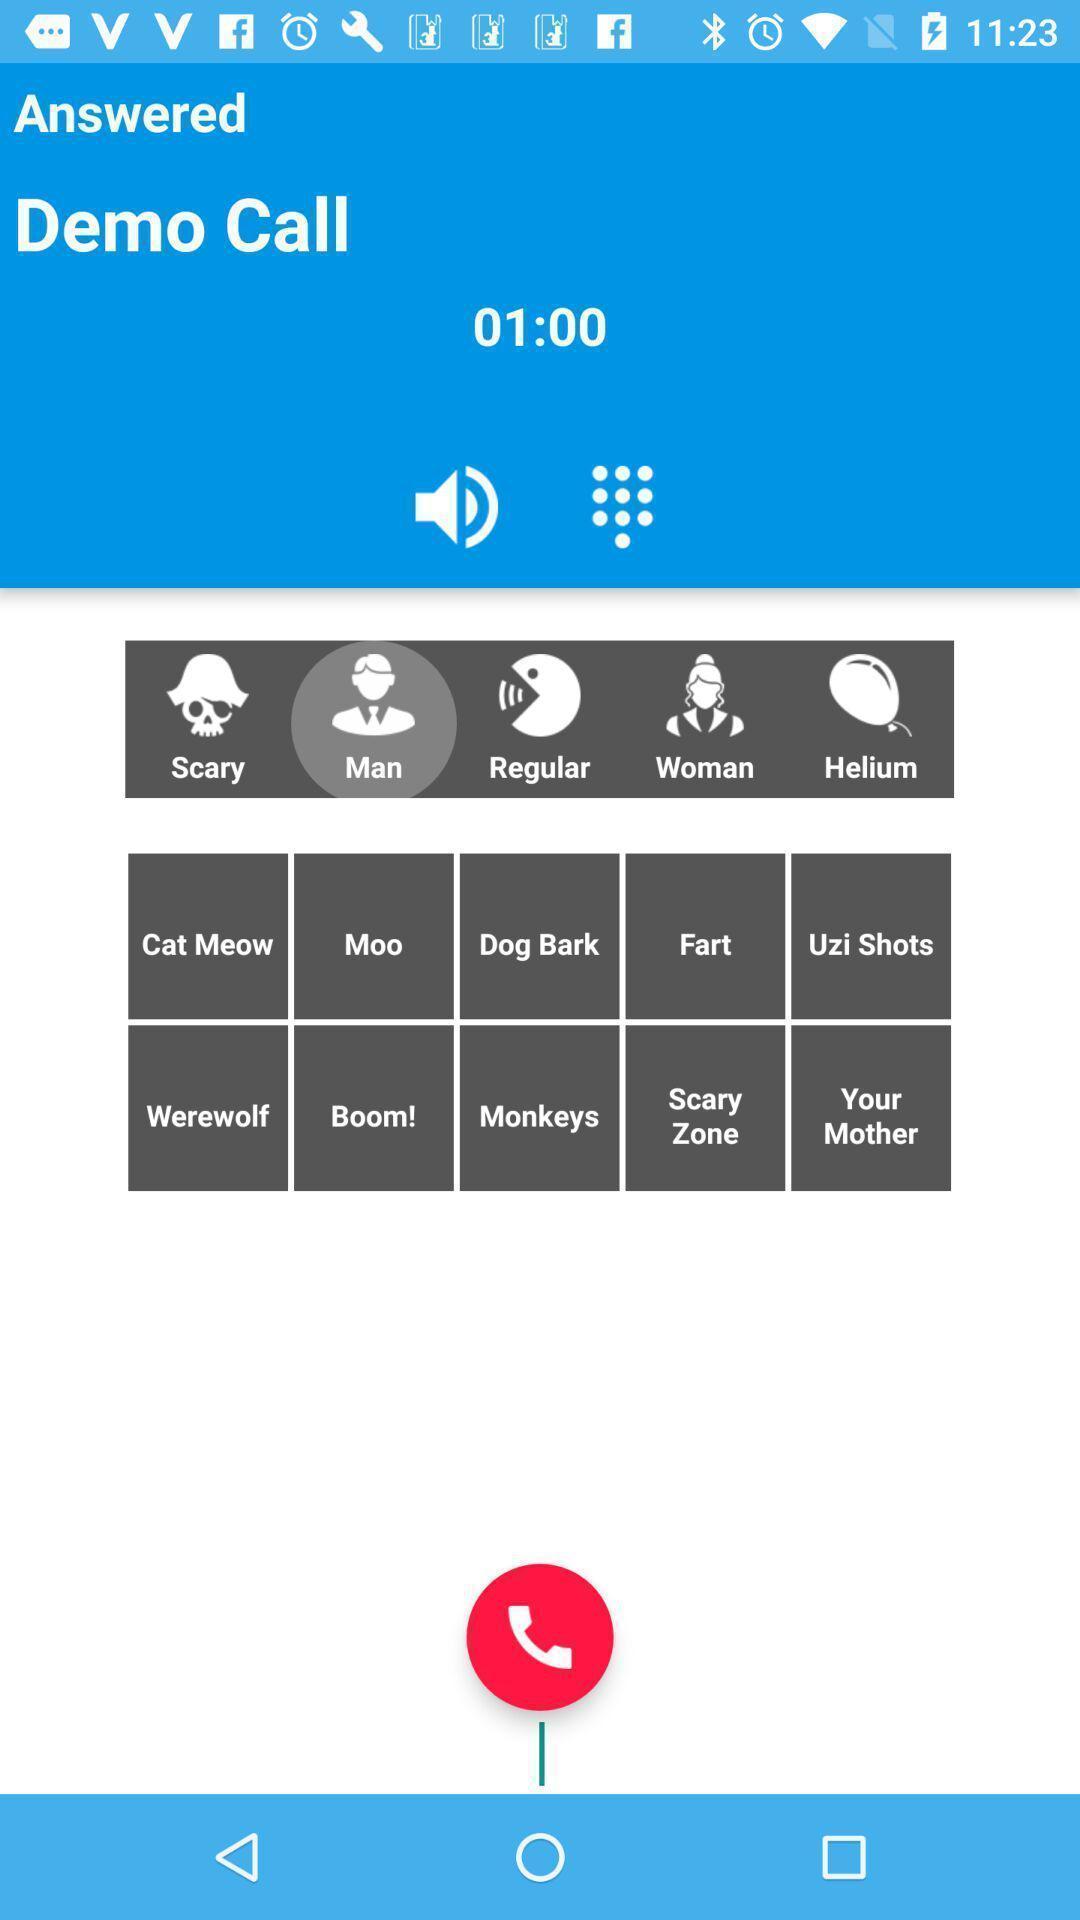Describe the key features of this screenshot. Screen showing demo call. 